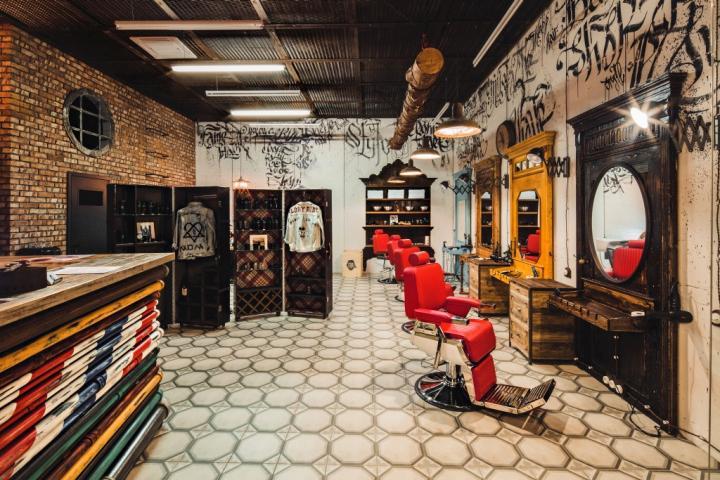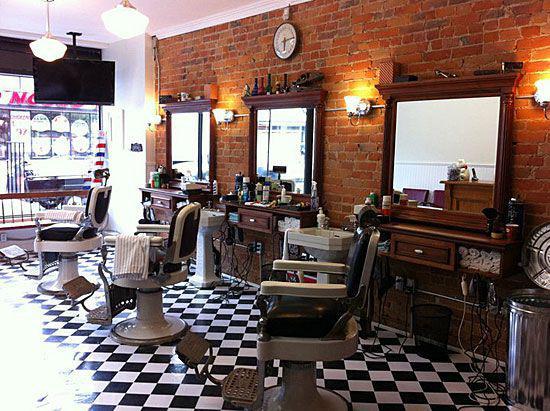The first image is the image on the left, the second image is the image on the right. Assess this claim about the two images: "In at least one image, a row of barber shop chairs sits on an intricate tiled floor.". Correct or not? Answer yes or no. Yes. 